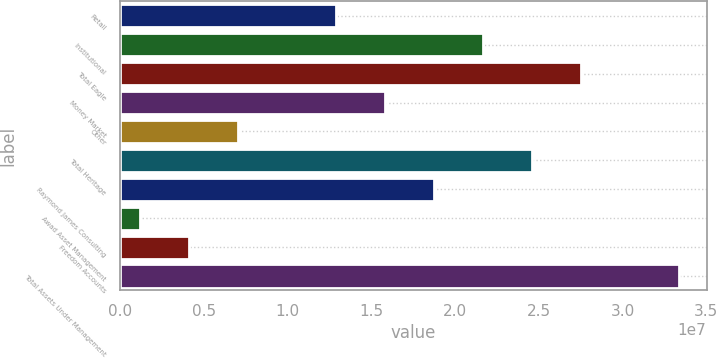Convert chart to OTSL. <chart><loc_0><loc_0><loc_500><loc_500><bar_chart><fcel>Retail<fcel>Institutional<fcel>Total Eagle<fcel>Money Market<fcel>Other<fcel>Total Heritage<fcel>Raymond James Consulting<fcel>Awad Asset Management<fcel>Freedom Accounts<fcel>Total Assets Under Management<nl><fcel>1.2905e+07<fcel>2.16671e+07<fcel>2.75085e+07<fcel>1.58257e+07<fcel>7.0636e+06<fcel>2.45878e+07<fcel>1.87464e+07<fcel>1.2222e+06<fcel>4.1429e+06<fcel>3.33499e+07<nl></chart> 